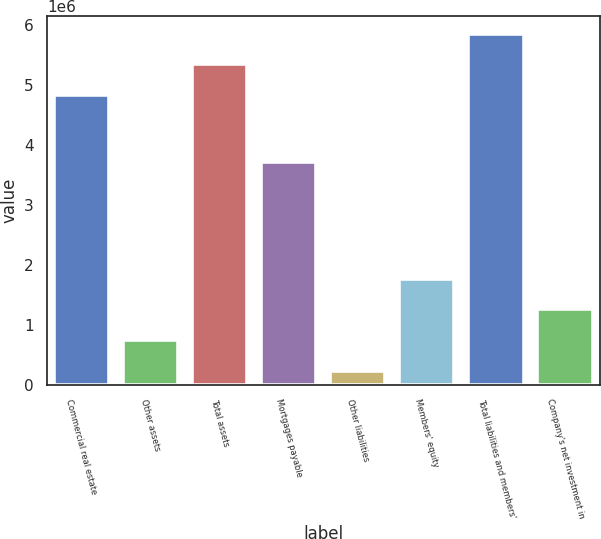<chart> <loc_0><loc_0><loc_500><loc_500><bar_chart><fcel>Commercial real estate<fcel>Other assets<fcel>Total assets<fcel>Mortgages payable<fcel>Other liabilities<fcel>Members' equity<fcel>Total liabilities and members'<fcel>Company's net investment in<nl><fcel>4.8319e+06<fcel>744911<fcel>5.34795e+06<fcel>3.71224e+06<fcel>233463<fcel>1.76781e+06<fcel>5.85939e+06<fcel>1.25636e+06<nl></chart> 